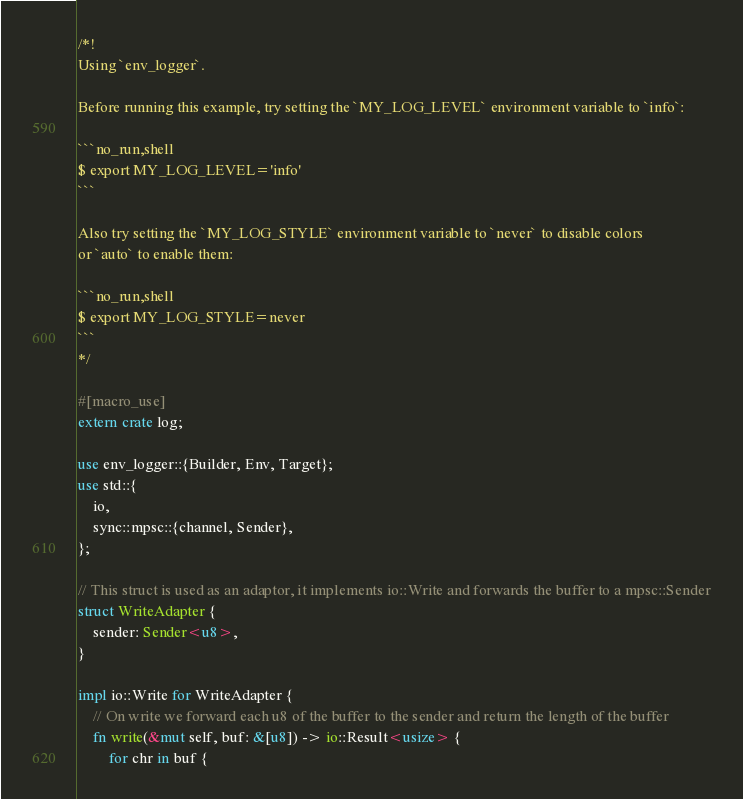<code> <loc_0><loc_0><loc_500><loc_500><_Rust_>/*!
Using `env_logger`.

Before running this example, try setting the `MY_LOG_LEVEL` environment variable to `info`:

```no_run,shell
$ export MY_LOG_LEVEL='info'
```

Also try setting the `MY_LOG_STYLE` environment variable to `never` to disable colors
or `auto` to enable them:

```no_run,shell
$ export MY_LOG_STYLE=never
```
*/

#[macro_use]
extern crate log;

use env_logger::{Builder, Env, Target};
use std::{
    io,
    sync::mpsc::{channel, Sender},
};

// This struct is used as an adaptor, it implements io::Write and forwards the buffer to a mpsc::Sender
struct WriteAdapter {
    sender: Sender<u8>,
}

impl io::Write for WriteAdapter {
    // On write we forward each u8 of the buffer to the sender and return the length of the buffer
    fn write(&mut self, buf: &[u8]) -> io::Result<usize> {
        for chr in buf {</code> 